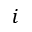Convert formula to latex. <formula><loc_0><loc_0><loc_500><loc_500>i</formula> 